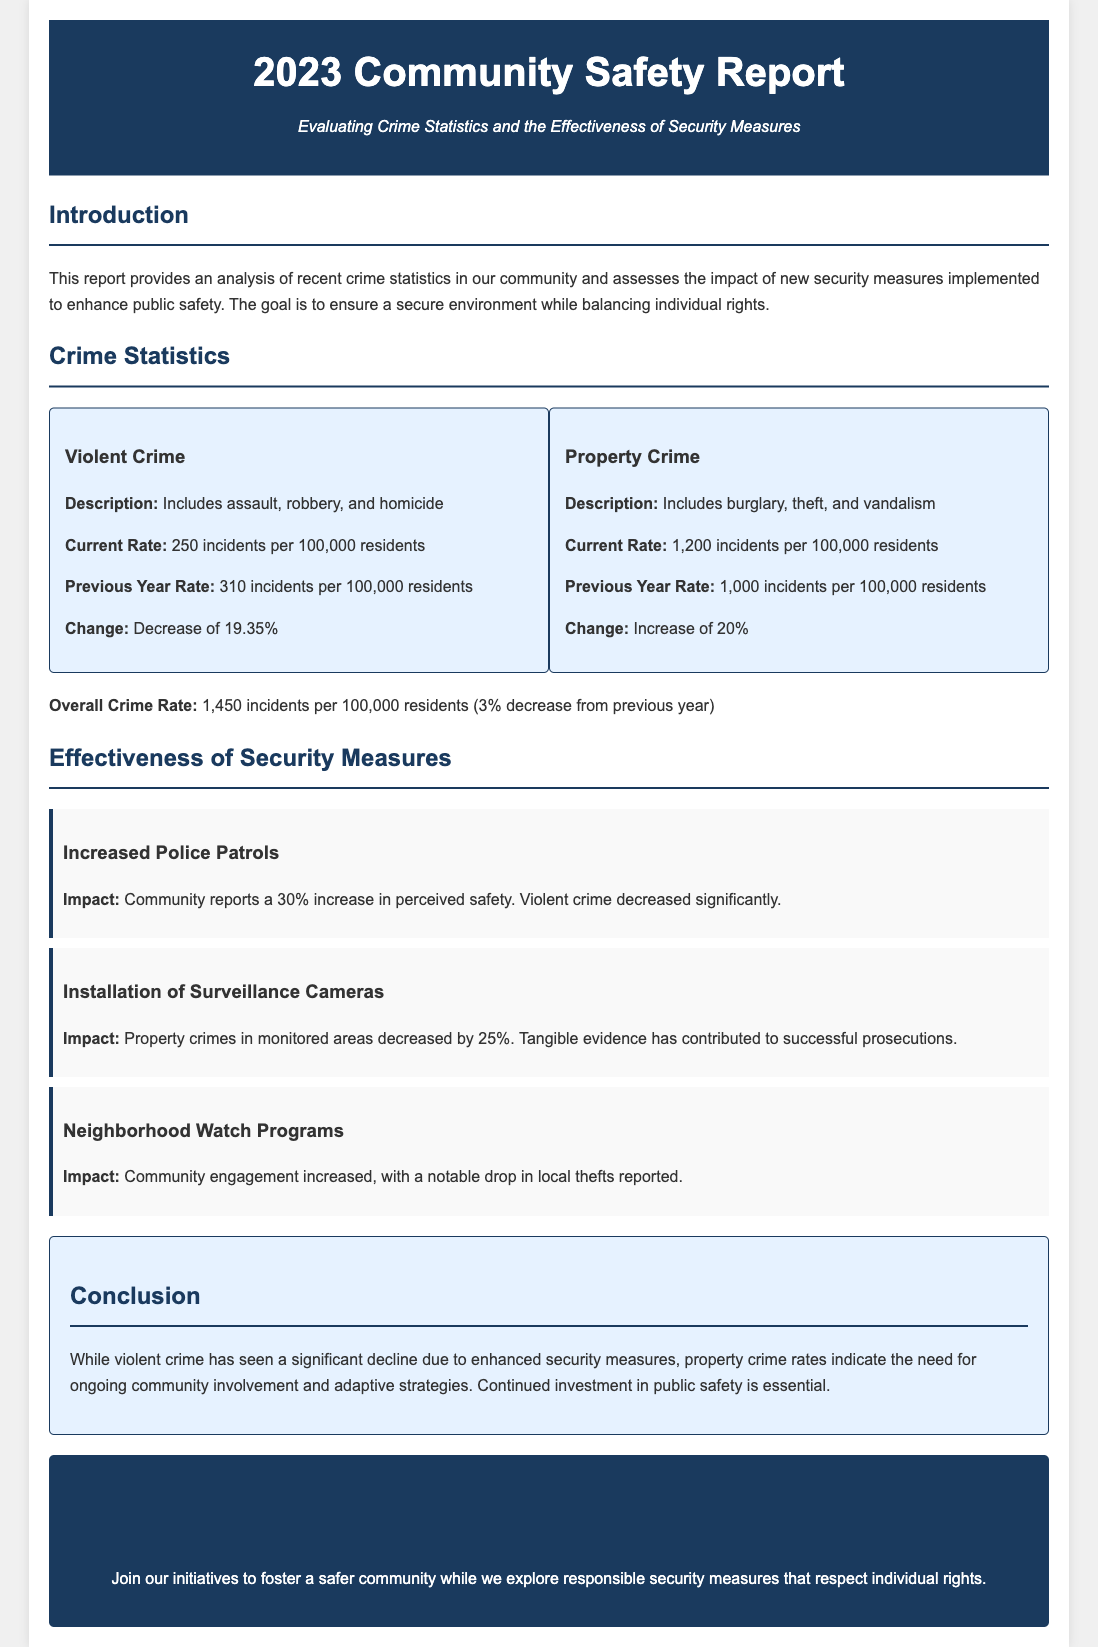What is the current rate of violent crime? The current rate of violent crime is specified in the document as 250 incidents per 100,000 residents.
Answer: 250 incidents per 100,000 residents What is the percentage decrease in violent crime from the previous year? The document states that there is a decrease of 19.35% in violent crime incidents compared to the previous year.
Answer: 19.35% What is the current rate of property crime? The current rate of property crime is mentioned in the document as 1,200 incidents per 100,000 residents.
Answer: 1,200 incidents per 100,000 residents What was the previous year rate of property crime? The previous year rate of property crime is listed as 1,000 incidents per 100,000 residents in the document.
Answer: 1,000 incidents per 100,000 residents How much did property crime increase by? The document indicates that property crime increased by 20% from the previous year.
Answer: 20% What impact did increased police patrols have on perceived safety? According to the document, increased police patrols resulted in a 30% increase in the community's perceived safety.
Answer: 30% By what percentage did property crimes decrease in monitored areas due to surveillance cameras? The document states that property crimes in monitored areas decreased by 25% due to the installation of surveillance cameras.
Answer: 25% What should the community continue to invest in according to the conclusion? The document emphasizes the necessity of continued investment in public safety as mentioned in the conclusion.
Answer: Public safety What is the overall crime rate reported in the document? The overall crime rate is stated as 1,450 incidents per 100,000 residents, with a 3% decrease from the previous year.
Answer: 1,450 incidents per 100,000 residents What initiative does the call to action encourage? The call to action encourages community members to join initiatives fostering a safer community through responsible security measures.
Answer: Initiatives to foster a safer community 